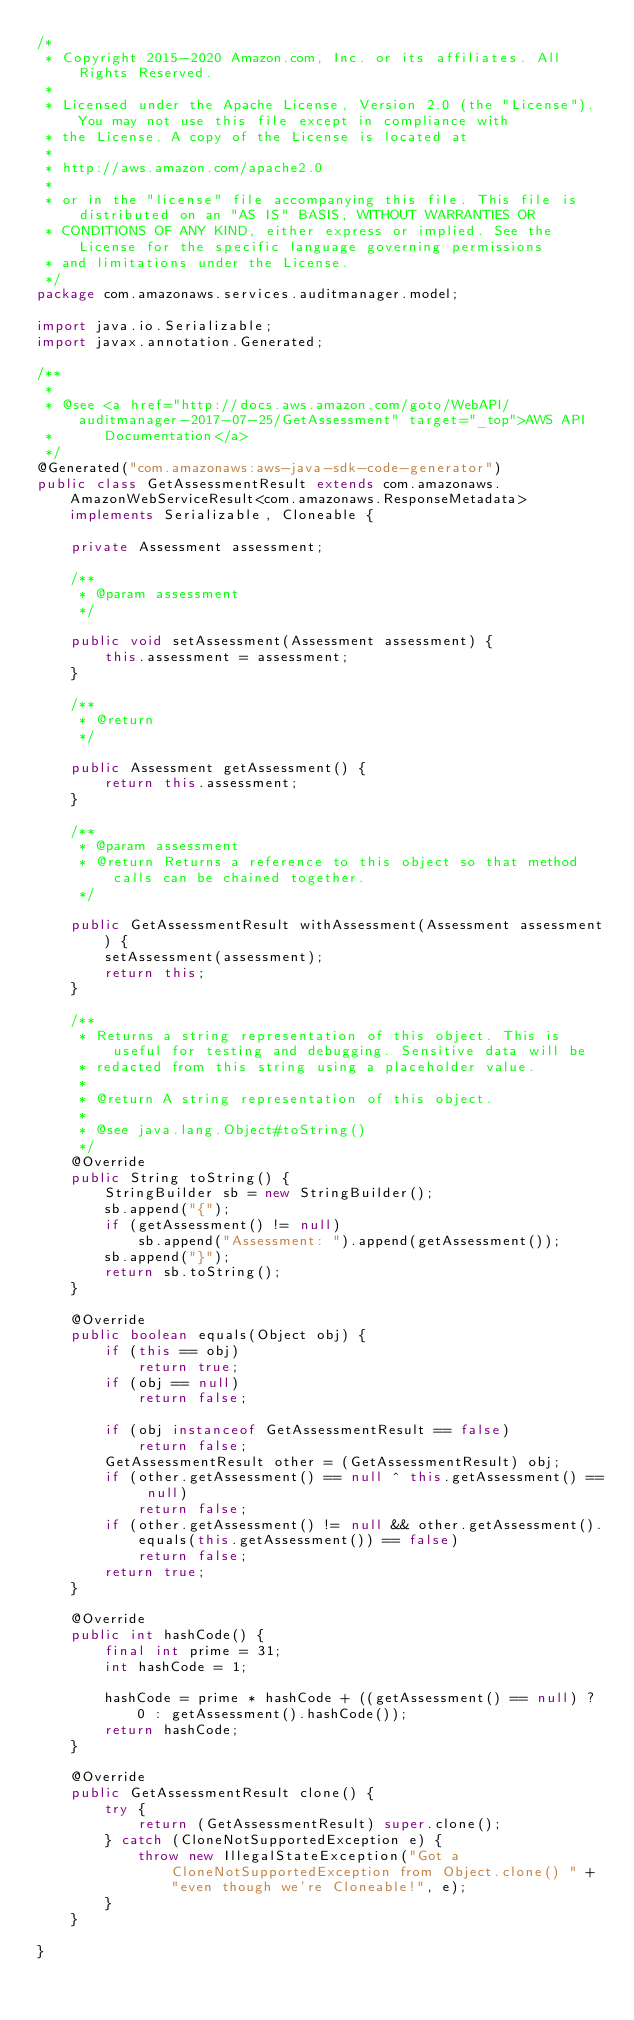<code> <loc_0><loc_0><loc_500><loc_500><_Java_>/*
 * Copyright 2015-2020 Amazon.com, Inc. or its affiliates. All Rights Reserved.
 * 
 * Licensed under the Apache License, Version 2.0 (the "License"). You may not use this file except in compliance with
 * the License. A copy of the License is located at
 * 
 * http://aws.amazon.com/apache2.0
 * 
 * or in the "license" file accompanying this file. This file is distributed on an "AS IS" BASIS, WITHOUT WARRANTIES OR
 * CONDITIONS OF ANY KIND, either express or implied. See the License for the specific language governing permissions
 * and limitations under the License.
 */
package com.amazonaws.services.auditmanager.model;

import java.io.Serializable;
import javax.annotation.Generated;

/**
 * 
 * @see <a href="http://docs.aws.amazon.com/goto/WebAPI/auditmanager-2017-07-25/GetAssessment" target="_top">AWS API
 *      Documentation</a>
 */
@Generated("com.amazonaws:aws-java-sdk-code-generator")
public class GetAssessmentResult extends com.amazonaws.AmazonWebServiceResult<com.amazonaws.ResponseMetadata> implements Serializable, Cloneable {

    private Assessment assessment;

    /**
     * @param assessment
     */

    public void setAssessment(Assessment assessment) {
        this.assessment = assessment;
    }

    /**
     * @return
     */

    public Assessment getAssessment() {
        return this.assessment;
    }

    /**
     * @param assessment
     * @return Returns a reference to this object so that method calls can be chained together.
     */

    public GetAssessmentResult withAssessment(Assessment assessment) {
        setAssessment(assessment);
        return this;
    }

    /**
     * Returns a string representation of this object. This is useful for testing and debugging. Sensitive data will be
     * redacted from this string using a placeholder value.
     *
     * @return A string representation of this object.
     *
     * @see java.lang.Object#toString()
     */
    @Override
    public String toString() {
        StringBuilder sb = new StringBuilder();
        sb.append("{");
        if (getAssessment() != null)
            sb.append("Assessment: ").append(getAssessment());
        sb.append("}");
        return sb.toString();
    }

    @Override
    public boolean equals(Object obj) {
        if (this == obj)
            return true;
        if (obj == null)
            return false;

        if (obj instanceof GetAssessmentResult == false)
            return false;
        GetAssessmentResult other = (GetAssessmentResult) obj;
        if (other.getAssessment() == null ^ this.getAssessment() == null)
            return false;
        if (other.getAssessment() != null && other.getAssessment().equals(this.getAssessment()) == false)
            return false;
        return true;
    }

    @Override
    public int hashCode() {
        final int prime = 31;
        int hashCode = 1;

        hashCode = prime * hashCode + ((getAssessment() == null) ? 0 : getAssessment().hashCode());
        return hashCode;
    }

    @Override
    public GetAssessmentResult clone() {
        try {
            return (GetAssessmentResult) super.clone();
        } catch (CloneNotSupportedException e) {
            throw new IllegalStateException("Got a CloneNotSupportedException from Object.clone() " + "even though we're Cloneable!", e);
        }
    }

}
</code> 